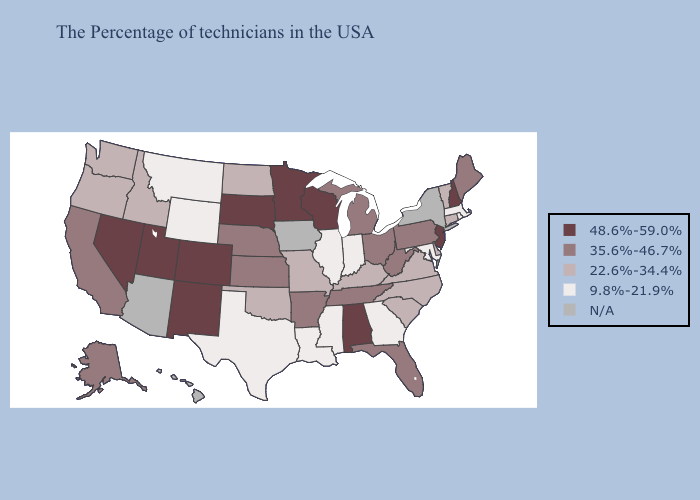Which states have the lowest value in the West?
Give a very brief answer. Wyoming, Montana. What is the lowest value in the South?
Write a very short answer. 9.8%-21.9%. What is the lowest value in the South?
Quick response, please. 9.8%-21.9%. Does Wisconsin have the highest value in the USA?
Answer briefly. Yes. Does the map have missing data?
Short answer required. Yes. Does Michigan have the highest value in the MidWest?
Keep it brief. No. Name the states that have a value in the range 22.6%-34.4%?
Write a very short answer. Vermont, Connecticut, Delaware, Virginia, North Carolina, South Carolina, Kentucky, Missouri, Oklahoma, North Dakota, Idaho, Washington, Oregon. What is the lowest value in states that border South Carolina?
Be succinct. 9.8%-21.9%. What is the lowest value in the USA?
Write a very short answer. 9.8%-21.9%. Does the map have missing data?
Keep it brief. Yes. Name the states that have a value in the range 22.6%-34.4%?
Give a very brief answer. Vermont, Connecticut, Delaware, Virginia, North Carolina, South Carolina, Kentucky, Missouri, Oklahoma, North Dakota, Idaho, Washington, Oregon. What is the value of North Carolina?
Concise answer only. 22.6%-34.4%. What is the highest value in the USA?
Concise answer only. 48.6%-59.0%. Which states hav the highest value in the MidWest?
Short answer required. Wisconsin, Minnesota, South Dakota. 